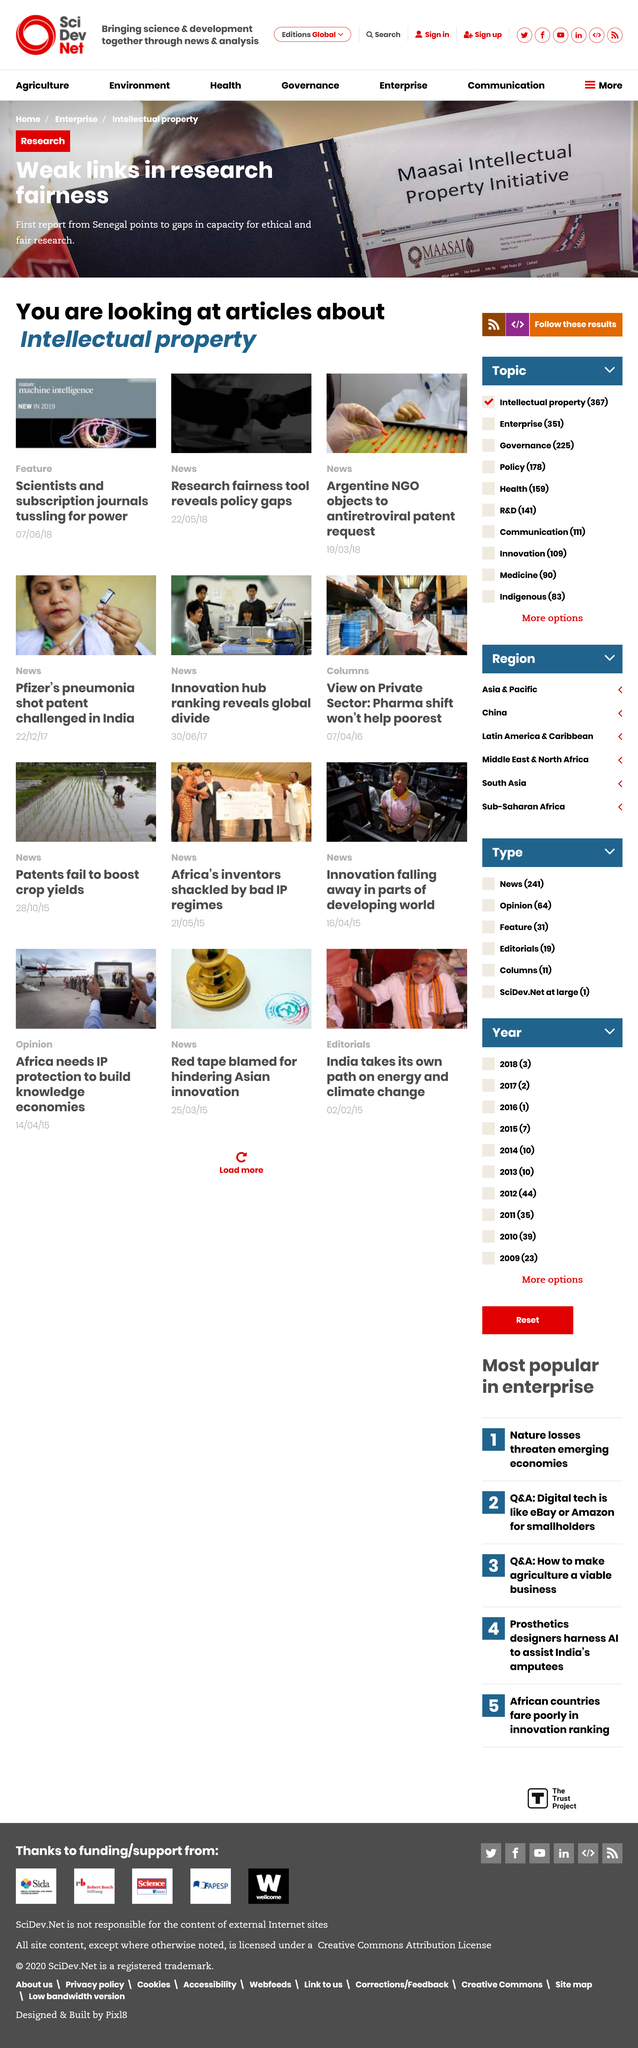Identify some key points in this picture. The articles on this page were written in the year 2018. This page contains articles of various types, including new articles, research articles, and features. The subject of these articles is intellectual property. 